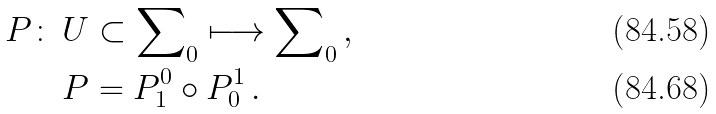Convert formula to latex. <formula><loc_0><loc_0><loc_500><loc_500>P \colon \, & U \subset \sum \nolimits _ { 0 } \longmapsto \sum \nolimits _ { 0 } \, , \\ & P = P _ { 1 } ^ { 0 } \circ P _ { 0 } ^ { 1 } \, .</formula> 